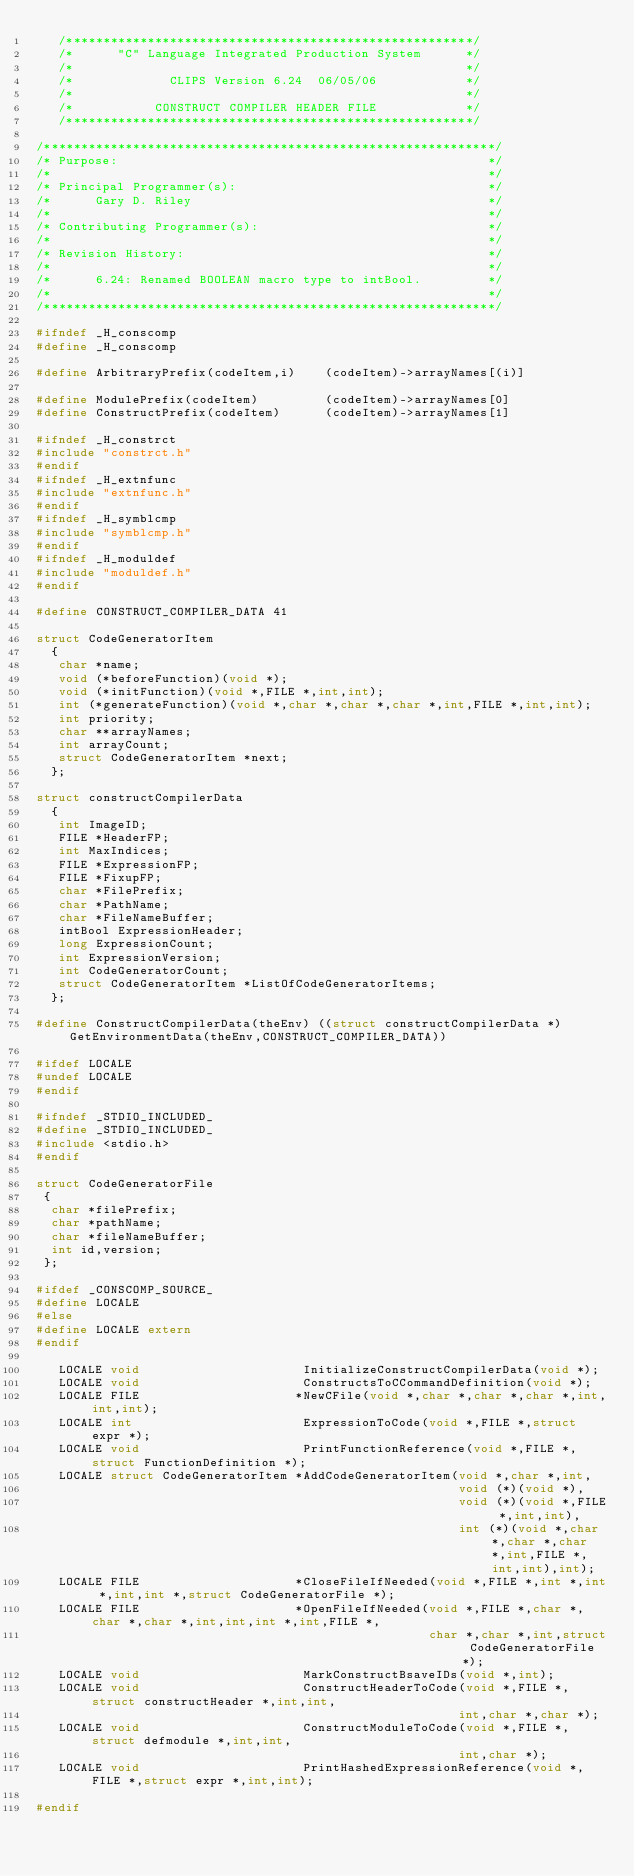<code> <loc_0><loc_0><loc_500><loc_500><_C_>   /*******************************************************/
   /*      "C" Language Integrated Production System      */
   /*                                                     */
   /*             CLIPS Version 6.24  06/05/06            */
   /*                                                     */
   /*           CONSTRUCT COMPILER HEADER FILE            */
   /*******************************************************/

/*************************************************************/
/* Purpose:                                                  */
/*                                                           */
/* Principal Programmer(s):                                  */
/*      Gary D. Riley                                        */
/*                                                           */
/* Contributing Programmer(s):                               */
/*                                                           */
/* Revision History:                                         */
/*                                                           */
/*      6.24: Renamed BOOLEAN macro type to intBool.         */
/*                                                           */
/*************************************************************/

#ifndef _H_conscomp
#define _H_conscomp

#define ArbitraryPrefix(codeItem,i)    (codeItem)->arrayNames[(i)]

#define ModulePrefix(codeItem)         (codeItem)->arrayNames[0]
#define ConstructPrefix(codeItem)      (codeItem)->arrayNames[1]

#ifndef _H_constrct
#include "constrct.h"
#endif
#ifndef _H_extnfunc
#include "extnfunc.h"
#endif
#ifndef _H_symblcmp
#include "symblcmp.h"
#endif
#ifndef _H_moduldef
#include "moduldef.h"
#endif

#define CONSTRUCT_COMPILER_DATA 41

struct CodeGeneratorItem
  {
   char *name;
   void (*beforeFunction)(void *);
   void (*initFunction)(void *,FILE *,int,int);
   int (*generateFunction)(void *,char *,char *,char *,int,FILE *,int,int);
   int priority;
   char **arrayNames;
   int arrayCount;
   struct CodeGeneratorItem *next;
  };

struct constructCompilerData
  { 
   int ImageID;
   FILE *HeaderFP;
   int MaxIndices;
   FILE *ExpressionFP;
   FILE *FixupFP;
   char *FilePrefix;
   char *PathName;
   char *FileNameBuffer;
   intBool ExpressionHeader;
   long ExpressionCount;
   int ExpressionVersion;
   int CodeGeneratorCount;
   struct CodeGeneratorItem *ListOfCodeGeneratorItems;
  };

#define ConstructCompilerData(theEnv) ((struct constructCompilerData *) GetEnvironmentData(theEnv,CONSTRUCT_COMPILER_DATA))

#ifdef LOCALE
#undef LOCALE
#endif

#ifndef _STDIO_INCLUDED_
#define _STDIO_INCLUDED_
#include <stdio.h>
#endif

struct CodeGeneratorFile
 {
  char *filePrefix;
  char *pathName;
  char *fileNameBuffer;
  int id,version;
 };

#ifdef _CONSCOMP_SOURCE_
#define LOCALE
#else
#define LOCALE extern
#endif

   LOCALE void                      InitializeConstructCompilerData(void *);
   LOCALE void                      ConstructsToCCommandDefinition(void *);
   LOCALE FILE                     *NewCFile(void *,char *,char *,char *,int,int,int);
   LOCALE int                       ExpressionToCode(void *,FILE *,struct expr *);
   LOCALE void                      PrintFunctionReference(void *,FILE *,struct FunctionDefinition *);
   LOCALE struct CodeGeneratorItem *AddCodeGeneratorItem(void *,char *,int,
                                                         void (*)(void *),
                                                         void (*)(void *,FILE *,int,int),
                                                         int (*)(void *,char *,char *,char *,int,FILE *,int,int),int);
   LOCALE FILE                     *CloseFileIfNeeded(void *,FILE *,int *,int *,int,int *,struct CodeGeneratorFile *);
   LOCALE FILE                     *OpenFileIfNeeded(void *,FILE *,char *,char *,char *,int,int,int *,int,FILE *,
                                                     char *,char *,int,struct CodeGeneratorFile *);
   LOCALE void                      MarkConstructBsaveIDs(void *,int);
   LOCALE void                      ConstructHeaderToCode(void *,FILE *,struct constructHeader *,int,int,
                                                         int,char *,char *);
   LOCALE void                      ConstructModuleToCode(void *,FILE *,struct defmodule *,int,int,
                                                         int,char *);
   LOCALE void                      PrintHashedExpressionReference(void *,FILE *,struct expr *,int,int);

#endif




</code> 